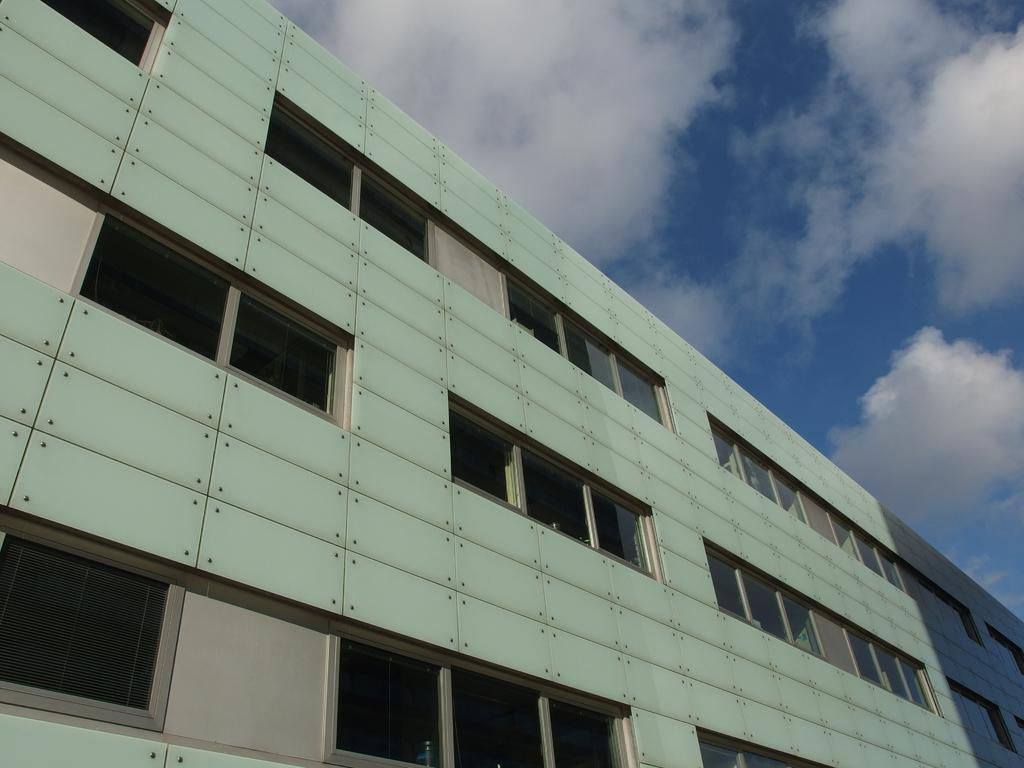What structure is present in the image? There is a building in the image. What feature can be observed on the building? The building has windows. What is visible in the background of the image? There is a sky visible in the background of the image. What can be seen in the sky in the image? There are clouds in the sky. What type of advertisement can be seen on the building in the image? There is no advertisement present on the building in the image. What type of material is the building made of, such as marble or brick? The type of material the building is made of cannot be determined from the image. 